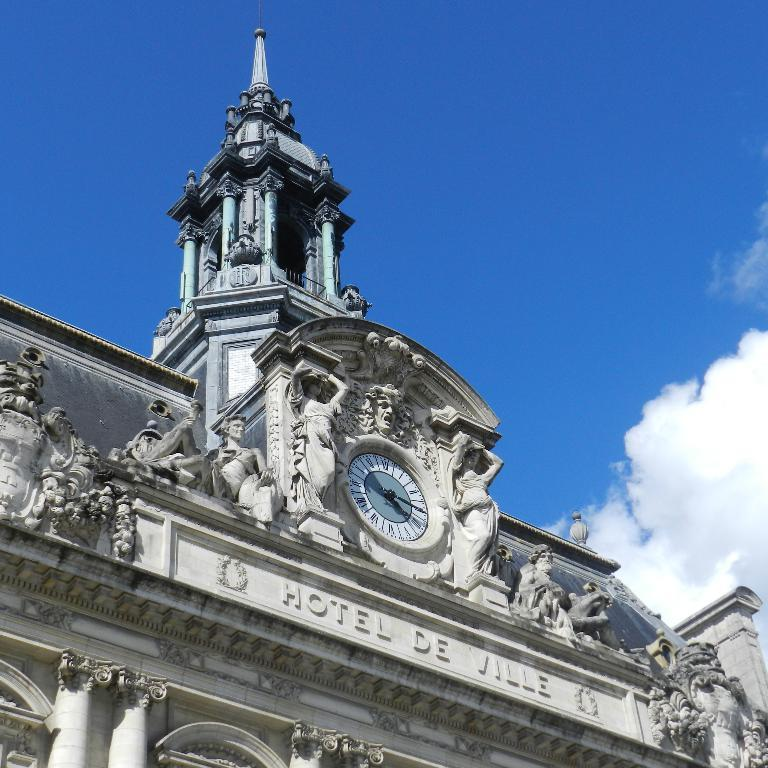<image>
Offer a succinct explanation of the picture presented. Writing on the front of a building identifies it as a hotel. 